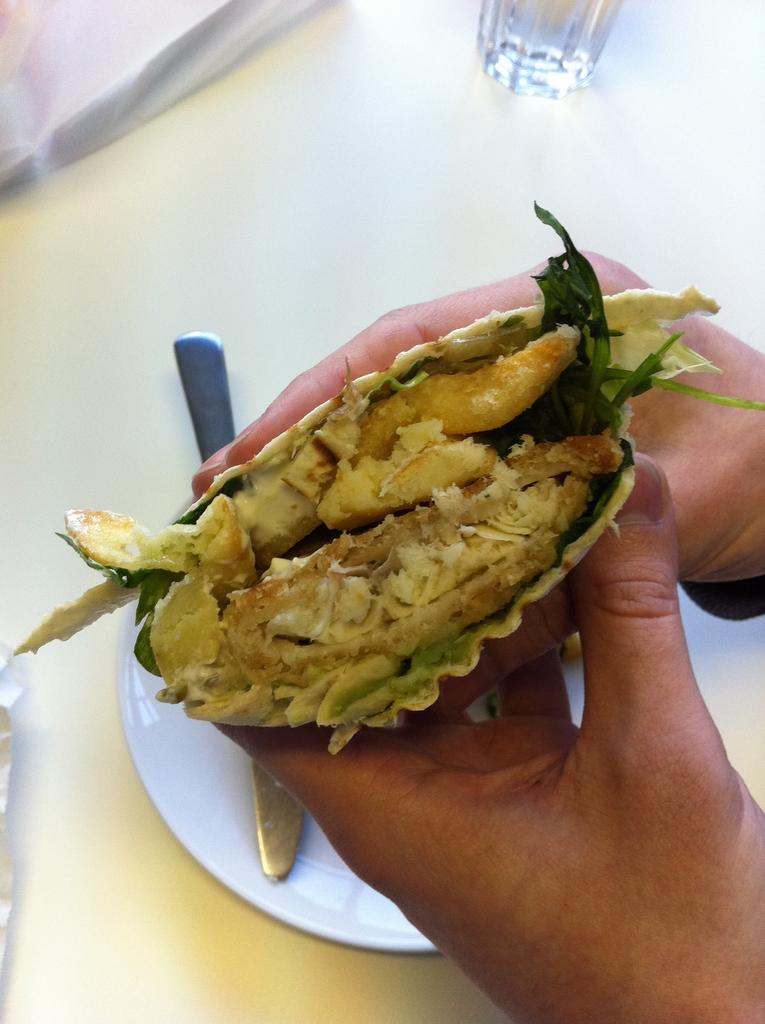What is being held by the hands in the image? There are hands holding food in the image. What utensil can be seen in the plate in the image? There is a knife in a plate in the image. What type of object is present to cover something in the image? There is a cover in the image. What type of container is visible on a surface in the image? There is a glass placed on a surface in the image. How many legs can be seen on the mom in the image? There is no mom present in the image, so it is not possible to determine the number of legs. What wish can be granted by the hands holding food in the image? There is no mention of a wish in the image; it simply shows hands holding food. 